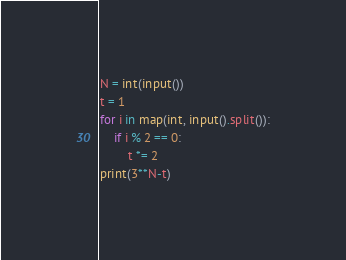Convert code to text. <code><loc_0><loc_0><loc_500><loc_500><_Python_>N = int(input())
t = 1
for i in map(int, input().split()):
    if i % 2 == 0:
        t *= 2
print(3**N-t)
</code> 